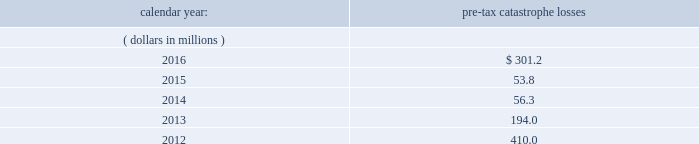Risks relating to our business fluctuations in the financial markets could result in investment losses .
Prolonged and severe disruptions in the overall public debt and equity markets , such as occurred during 2008 , could result in significant realized and unrealized losses in our investment portfolio .
Although financial markets have significantly improved since 2008 , they could deteriorate in the future .
There could also be disruption in individual market sectors , such as occurred in the energy sector in recent years .
Such declines in the financial markets could result in significant realized and unrealized losses on investments and could have a material adverse impact on our results of operations , equity , business and insurer financial strength and debt ratings .
Our results could be adversely affected by catastrophic events .
We are exposed to unpredictable catastrophic events , including weather-related and other natural catastrophes , as well as acts of terrorism .
Any material reduction in our operating results caused by the occurrence of one or more catastrophes could inhibit our ability to pay dividends or to meet our interest and principal payment obligations .
By way of illustration , during the past five calendar years , pre-tax catastrophe losses , net of contract specific reinsurance but before cessions under corporate reinsurance programs , were as follows: .
Our losses from future catastrophic events could exceed our projections .
We use projections of possible losses from future catastrophic events of varying types and magnitudes as a strategic underwriting tool .
We use these loss projections to estimate our potential catastrophe losses in certain geographic areas and decide on the placement of retrocessional coverage or other actions to limit the extent of potential losses in a given geographic area .
These loss projections are approximations , reliant on a mix of quantitative and qualitative processes , and actual losses may exceed the projections by a material amount , resulting in a material adverse effect on our financial condition and results of operations. .
What was the percentage change in the pre-tax catastrophe losses from 2015 to 2016? 
Computations: ((301.2 - 53.8) / 53.8)
Answer: 4.59851. Risks relating to our business fluctuations in the financial markets could result in investment losses .
Prolonged and severe disruptions in the overall public debt and equity markets , such as occurred during 2008 , could result in significant realized and unrealized losses in our investment portfolio .
Although financial markets have significantly improved since 2008 , they could deteriorate in the future .
There could also be disruption in individual market sectors , such as occurred in the energy sector in recent years .
Such declines in the financial markets could result in significant realized and unrealized losses on investments and could have a material adverse impact on our results of operations , equity , business and insurer financial strength and debt ratings .
Our results could be adversely affected by catastrophic events .
We are exposed to unpredictable catastrophic events , including weather-related and other natural catastrophes , as well as acts of terrorism .
Any material reduction in our operating results caused by the occurrence of one or more catastrophes could inhibit our ability to pay dividends or to meet our interest and principal payment obligations .
By way of illustration , during the past five calendar years , pre-tax catastrophe losses , net of contract specific reinsurance but before cessions under corporate reinsurance programs , were as follows: .
Our losses from future catastrophic events could exceed our projections .
We use projections of possible losses from future catastrophic events of varying types and magnitudes as a strategic underwriting tool .
We use these loss projections to estimate our potential catastrophe losses in certain geographic areas and decide on the placement of retrocessional coverage or other actions to limit the extent of potential losses in a given geographic area .
These loss projections are approximations , reliant on a mix of quantitative and qualitative processes , and actual losses may exceed the projections by a material amount , resulting in a material adverse effect on our financial condition and results of operations. .
What are the total pre-tax catastrophe losses in the last five years?\\n? 
Computations: ((((301.2 + 53.8) + 56.3) + 194.0) + 410.0)
Answer: 1015.3. 